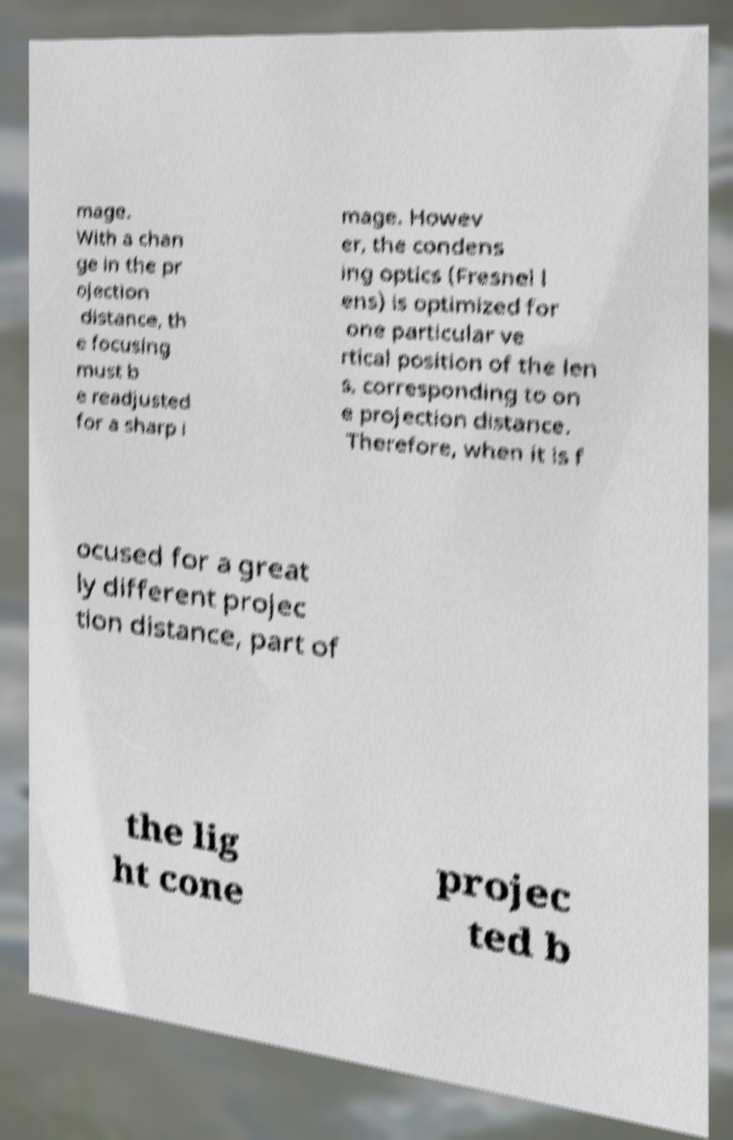There's text embedded in this image that I need extracted. Can you transcribe it verbatim? mage. With a chan ge in the pr ojection distance, th e focusing must b e readjusted for a sharp i mage. Howev er, the condens ing optics (Fresnel l ens) is optimized for one particular ve rtical position of the len s, corresponding to on e projection distance. Therefore, when it is f ocused for a great ly different projec tion distance, part of the lig ht cone projec ted b 